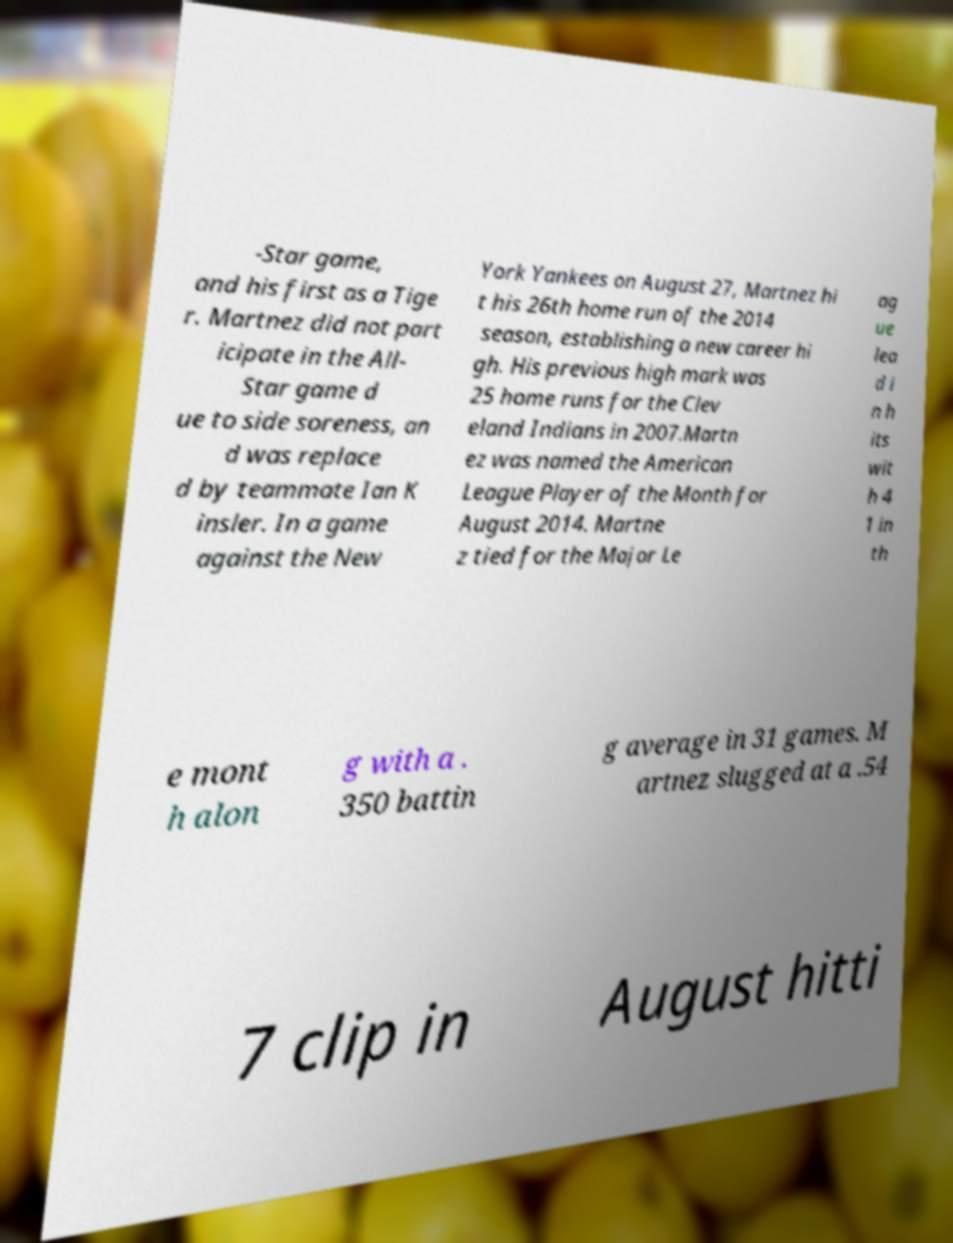Please read and relay the text visible in this image. What does it say? -Star game, and his first as a Tige r. Martnez did not part icipate in the All- Star game d ue to side soreness, an d was replace d by teammate Ian K insler. In a game against the New York Yankees on August 27, Martnez hi t his 26th home run of the 2014 season, establishing a new career hi gh. His previous high mark was 25 home runs for the Clev eland Indians in 2007.Martn ez was named the American League Player of the Month for August 2014. Martne z tied for the Major Le ag ue lea d i n h its wit h 4 1 in th e mont h alon g with a . 350 battin g average in 31 games. M artnez slugged at a .54 7 clip in August hitti 